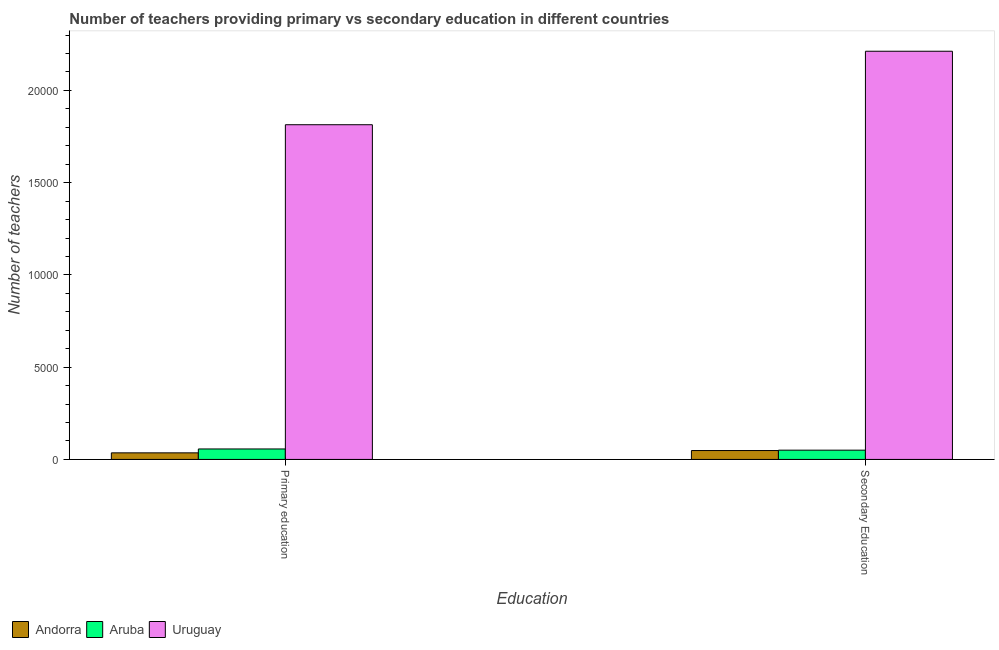How many groups of bars are there?
Ensure brevity in your answer.  2. Are the number of bars on each tick of the X-axis equal?
Provide a succinct answer. Yes. How many bars are there on the 2nd tick from the right?
Give a very brief answer. 3. What is the label of the 1st group of bars from the left?
Keep it short and to the point. Primary education. What is the number of primary teachers in Uruguay?
Give a very brief answer. 1.81e+04. Across all countries, what is the maximum number of secondary teachers?
Offer a terse response. 2.21e+04. Across all countries, what is the minimum number of secondary teachers?
Offer a terse response. 482. In which country was the number of secondary teachers maximum?
Your response must be concise. Uruguay. In which country was the number of secondary teachers minimum?
Offer a terse response. Andorra. What is the total number of primary teachers in the graph?
Provide a short and direct response. 1.91e+04. What is the difference between the number of primary teachers in Andorra and that in Uruguay?
Your answer should be very brief. -1.78e+04. What is the difference between the number of primary teachers in Uruguay and the number of secondary teachers in Andorra?
Keep it short and to the point. 1.77e+04. What is the average number of primary teachers per country?
Your answer should be very brief. 6354. What is the difference between the number of secondary teachers and number of primary teachers in Aruba?
Offer a very short reply. -65. In how many countries, is the number of primary teachers greater than 11000 ?
Make the answer very short. 1. What is the ratio of the number of primary teachers in Andorra to that in Aruba?
Ensure brevity in your answer.  0.63. What does the 3rd bar from the left in Secondary Education represents?
Ensure brevity in your answer.  Uruguay. What does the 3rd bar from the right in Secondary Education represents?
Give a very brief answer. Andorra. Are all the bars in the graph horizontal?
Your answer should be compact. No. How many countries are there in the graph?
Offer a terse response. 3. Does the graph contain any zero values?
Offer a terse response. No. Does the graph contain grids?
Your answer should be compact. No. Where does the legend appear in the graph?
Provide a succinct answer. Bottom left. What is the title of the graph?
Keep it short and to the point. Number of teachers providing primary vs secondary education in different countries. What is the label or title of the X-axis?
Ensure brevity in your answer.  Education. What is the label or title of the Y-axis?
Your response must be concise. Number of teachers. What is the Number of teachers of Andorra in Primary education?
Offer a very short reply. 356. What is the Number of teachers in Aruba in Primary education?
Provide a short and direct response. 567. What is the Number of teachers of Uruguay in Primary education?
Keep it short and to the point. 1.81e+04. What is the Number of teachers in Andorra in Secondary Education?
Provide a short and direct response. 482. What is the Number of teachers of Aruba in Secondary Education?
Offer a terse response. 502. What is the Number of teachers of Uruguay in Secondary Education?
Offer a terse response. 2.21e+04. Across all Education, what is the maximum Number of teachers in Andorra?
Provide a short and direct response. 482. Across all Education, what is the maximum Number of teachers in Aruba?
Give a very brief answer. 567. Across all Education, what is the maximum Number of teachers of Uruguay?
Offer a very short reply. 2.21e+04. Across all Education, what is the minimum Number of teachers of Andorra?
Offer a terse response. 356. Across all Education, what is the minimum Number of teachers in Aruba?
Your answer should be very brief. 502. Across all Education, what is the minimum Number of teachers in Uruguay?
Give a very brief answer. 1.81e+04. What is the total Number of teachers of Andorra in the graph?
Offer a very short reply. 838. What is the total Number of teachers in Aruba in the graph?
Give a very brief answer. 1069. What is the total Number of teachers of Uruguay in the graph?
Your answer should be compact. 4.03e+04. What is the difference between the Number of teachers of Andorra in Primary education and that in Secondary Education?
Give a very brief answer. -126. What is the difference between the Number of teachers in Aruba in Primary education and that in Secondary Education?
Provide a succinct answer. 65. What is the difference between the Number of teachers of Uruguay in Primary education and that in Secondary Education?
Provide a succinct answer. -3983. What is the difference between the Number of teachers in Andorra in Primary education and the Number of teachers in Aruba in Secondary Education?
Provide a short and direct response. -146. What is the difference between the Number of teachers in Andorra in Primary education and the Number of teachers in Uruguay in Secondary Education?
Provide a succinct answer. -2.18e+04. What is the difference between the Number of teachers in Aruba in Primary education and the Number of teachers in Uruguay in Secondary Education?
Provide a short and direct response. -2.16e+04. What is the average Number of teachers of Andorra per Education?
Your answer should be very brief. 419. What is the average Number of teachers of Aruba per Education?
Make the answer very short. 534.5. What is the average Number of teachers of Uruguay per Education?
Offer a very short reply. 2.01e+04. What is the difference between the Number of teachers in Andorra and Number of teachers in Aruba in Primary education?
Your answer should be compact. -211. What is the difference between the Number of teachers of Andorra and Number of teachers of Uruguay in Primary education?
Your response must be concise. -1.78e+04. What is the difference between the Number of teachers of Aruba and Number of teachers of Uruguay in Primary education?
Give a very brief answer. -1.76e+04. What is the difference between the Number of teachers in Andorra and Number of teachers in Uruguay in Secondary Education?
Ensure brevity in your answer.  -2.16e+04. What is the difference between the Number of teachers of Aruba and Number of teachers of Uruguay in Secondary Education?
Provide a succinct answer. -2.16e+04. What is the ratio of the Number of teachers in Andorra in Primary education to that in Secondary Education?
Offer a terse response. 0.74. What is the ratio of the Number of teachers of Aruba in Primary education to that in Secondary Education?
Your answer should be compact. 1.13. What is the ratio of the Number of teachers of Uruguay in Primary education to that in Secondary Education?
Provide a succinct answer. 0.82. What is the difference between the highest and the second highest Number of teachers in Andorra?
Give a very brief answer. 126. What is the difference between the highest and the second highest Number of teachers of Aruba?
Provide a short and direct response. 65. What is the difference between the highest and the second highest Number of teachers of Uruguay?
Make the answer very short. 3983. What is the difference between the highest and the lowest Number of teachers of Andorra?
Your answer should be very brief. 126. What is the difference between the highest and the lowest Number of teachers of Aruba?
Keep it short and to the point. 65. What is the difference between the highest and the lowest Number of teachers in Uruguay?
Provide a succinct answer. 3983. 